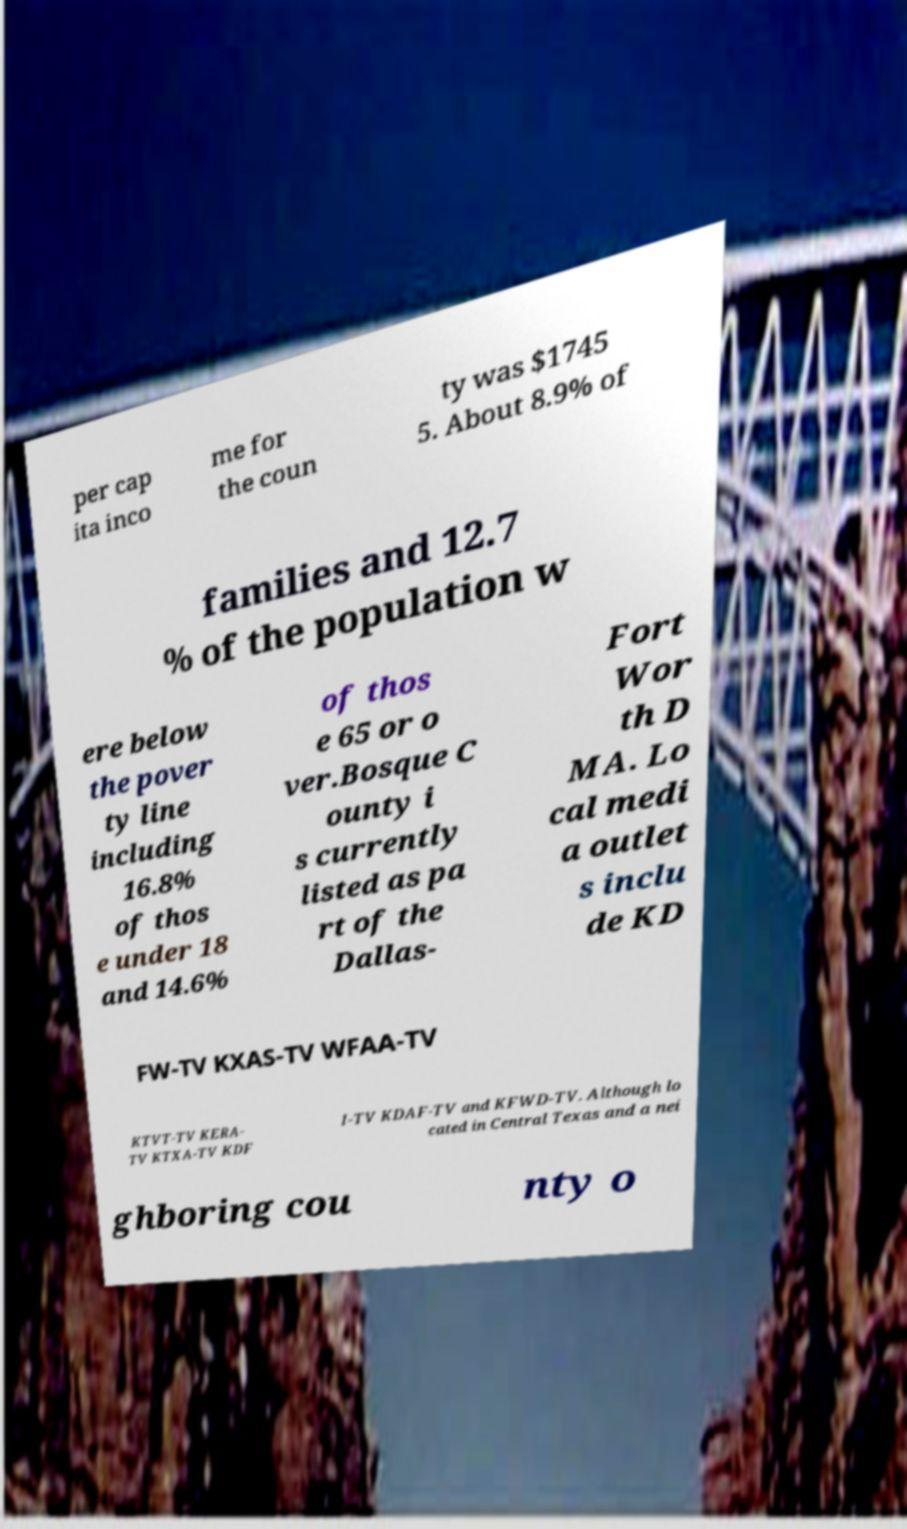For documentation purposes, I need the text within this image transcribed. Could you provide that? per cap ita inco me for the coun ty was $1745 5. About 8.9% of families and 12.7 % of the population w ere below the pover ty line including 16.8% of thos e under 18 and 14.6% of thos e 65 or o ver.Bosque C ounty i s currently listed as pa rt of the Dallas- Fort Wor th D MA. Lo cal medi a outlet s inclu de KD FW-TV KXAS-TV WFAA-TV KTVT-TV KERA- TV KTXA-TV KDF I-TV KDAF-TV and KFWD-TV. Although lo cated in Central Texas and a nei ghboring cou nty o 